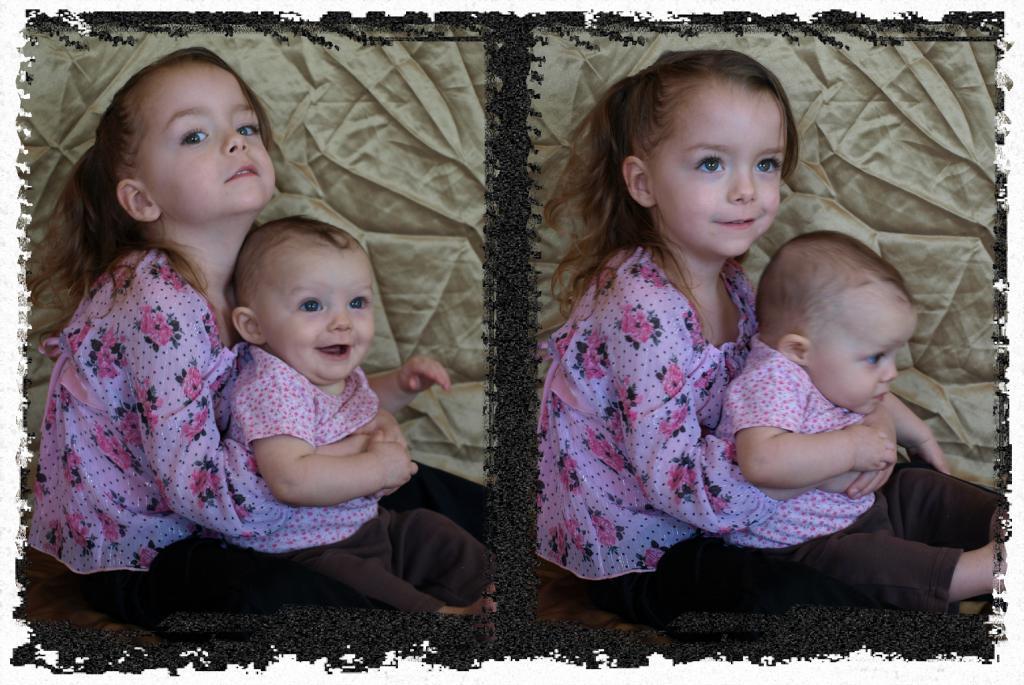Describe this image in one or two sentences. In this image we can see a collage of two pictures in which we can see a girl holding a baby with her hands. In the background, we can see the cloth. 